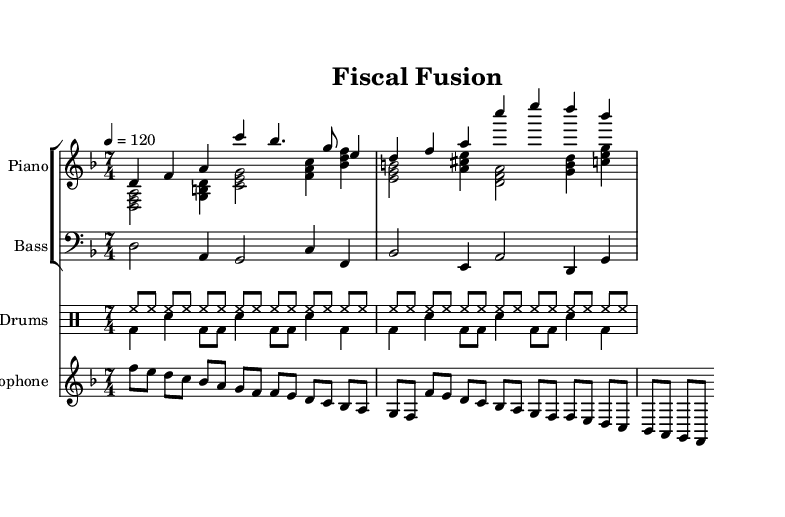What is the key signature of this music? The key signature is D minor, which typically contains one flat (C). It can be identified from the key signature notation at the beginning of the sheet music.
Answer: D minor What is the time signature of this composition? The time signature is seven-four, noted at the beginning of the music. It indicates that there are seven beats in each measure, and a quarter note receives one beat.
Answer: 7/4 What is the tempo marking given in the sheet music? The tempo marking is quarter note equals 120, indicated at the beginning. This tells the performer to play at a moderate tempo of 120 beats per minute.
Answer: 120 How many measures are in the piano right-hand part? The piano right-hand part consists of two measures, which can be counted by looking at the number of vertical bar lines in the respective staff.
Answer: 2 Which instruments are included in this composition? The composition includes piano, bass, drums, and saxophone, identifiable by the different staffs labeled for each instrument in the score.
Answer: Piano, bass, drums, saxophone What type of rhythmic structure is used in the drum staff? The drum staff presents a combination of eighth notes and quarter notes, emphasizing a swing feel common in jazz. This can be observed by analyzing the drum patterns and their respective note values.
Answer: Swing feel What economic concept is reflected in the title "Fiscal Fusion"? The title "Fiscal Fusion" suggests a blend of musical styles with economic themes, possibly indicating the interplay of different economic theories. This interpretation arises from considering the terms 'fiscal' (related to government or economy) and 'fusion' (merging styles).
Answer: Economic themes 